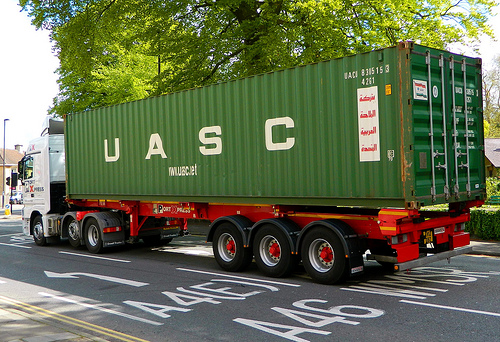Which kind of vehicle is left of the container? The vehicle that is positioned to the left of the container is a taxi. 